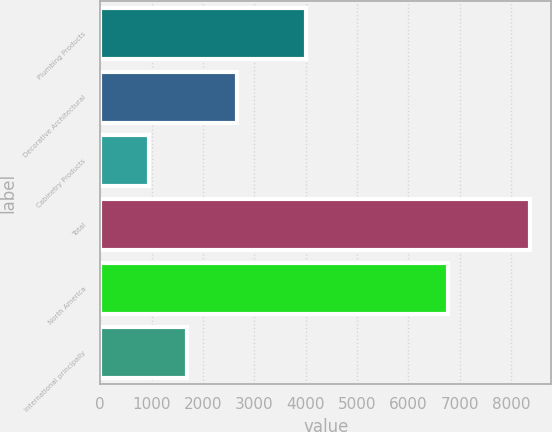<chart> <loc_0><loc_0><loc_500><loc_500><bar_chart><fcel>Plumbing Products<fcel>Decorative Architectural<fcel>Cabinetry Products<fcel>Total<fcel>North America<fcel>International principally<nl><fcel>3998<fcel>2656<fcel>950<fcel>8359<fcel>6763<fcel>1690.9<nl></chart> 